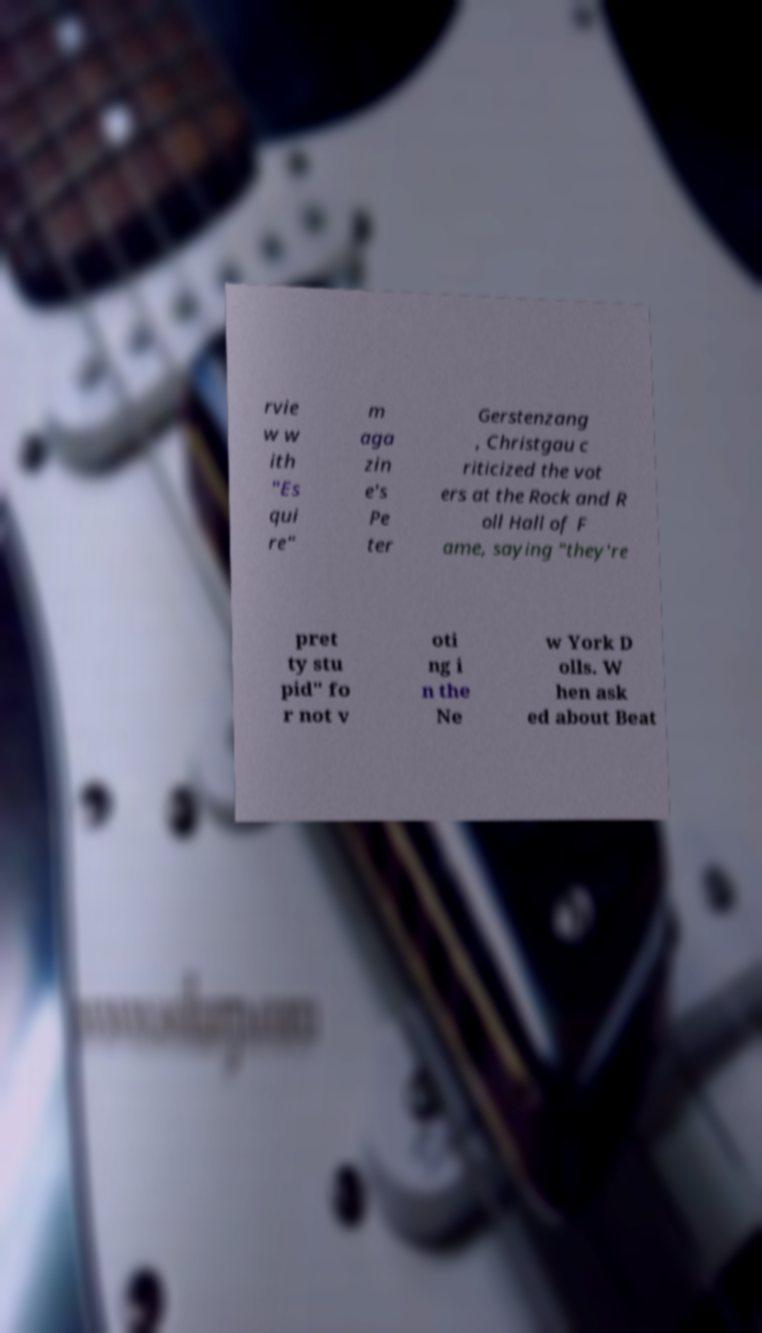I need the written content from this picture converted into text. Can you do that? rvie w w ith "Es qui re" m aga zin e's Pe ter Gerstenzang , Christgau c riticized the vot ers at the Rock and R oll Hall of F ame, saying "they're pret ty stu pid" fo r not v oti ng i n the Ne w York D olls. W hen ask ed about Beat 